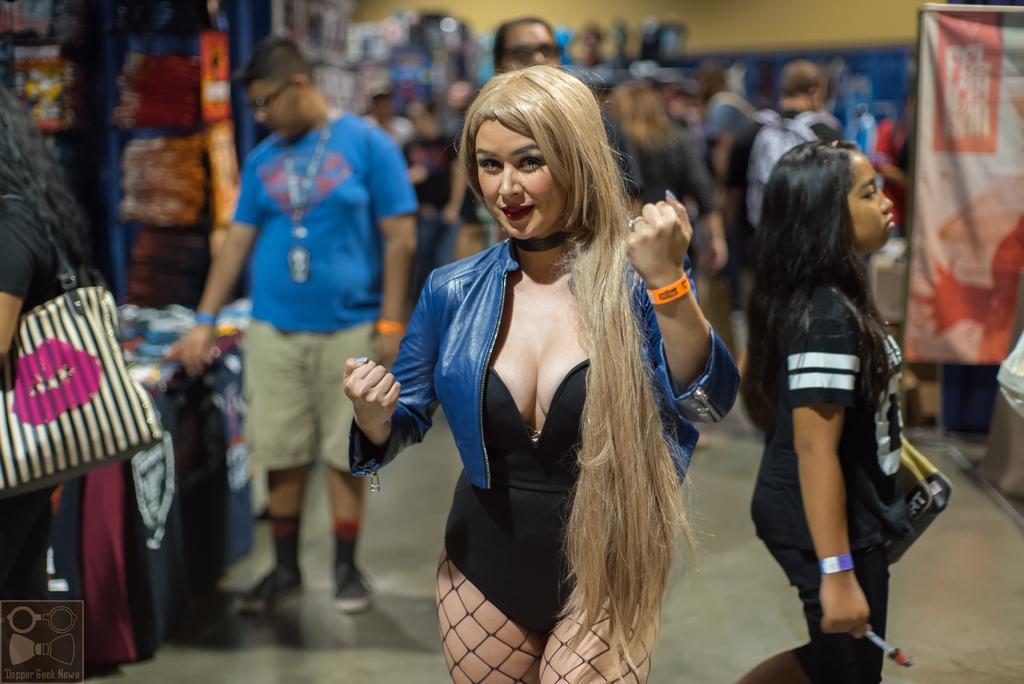Describe this image in one or two sentences. In this image we can see a person wearing black color dress, blue color jacket, also wearing orange color wrist band standing and in the background of the image there are some persons standing, there are some stores. 